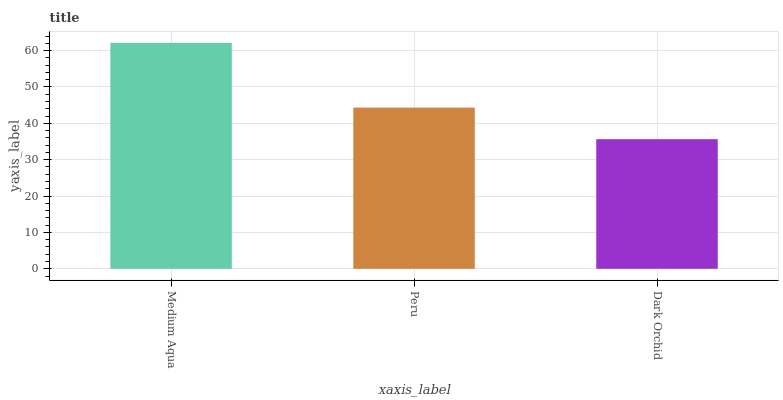Is Dark Orchid the minimum?
Answer yes or no. Yes. Is Medium Aqua the maximum?
Answer yes or no. Yes. Is Peru the minimum?
Answer yes or no. No. Is Peru the maximum?
Answer yes or no. No. Is Medium Aqua greater than Peru?
Answer yes or no. Yes. Is Peru less than Medium Aqua?
Answer yes or no. Yes. Is Peru greater than Medium Aqua?
Answer yes or no. No. Is Medium Aqua less than Peru?
Answer yes or no. No. Is Peru the high median?
Answer yes or no. Yes. Is Peru the low median?
Answer yes or no. Yes. Is Medium Aqua the high median?
Answer yes or no. No. Is Medium Aqua the low median?
Answer yes or no. No. 